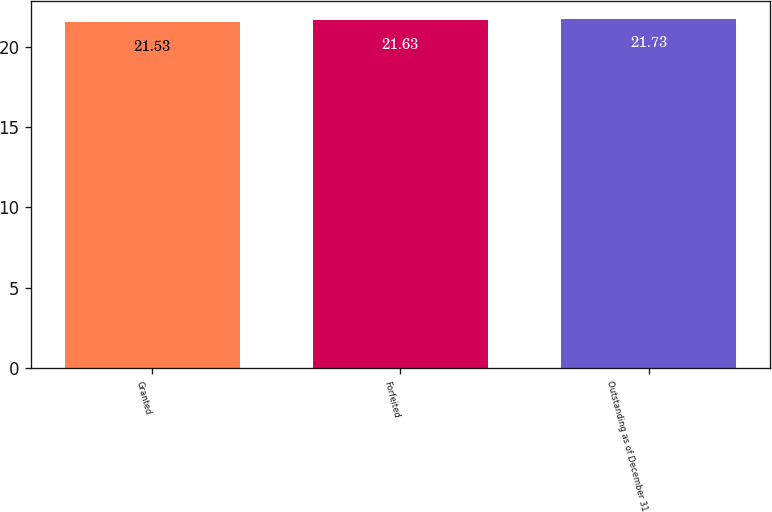Convert chart. <chart><loc_0><loc_0><loc_500><loc_500><bar_chart><fcel>Granted<fcel>Forfeited<fcel>Outstanding as of December 31<nl><fcel>21.53<fcel>21.63<fcel>21.73<nl></chart> 